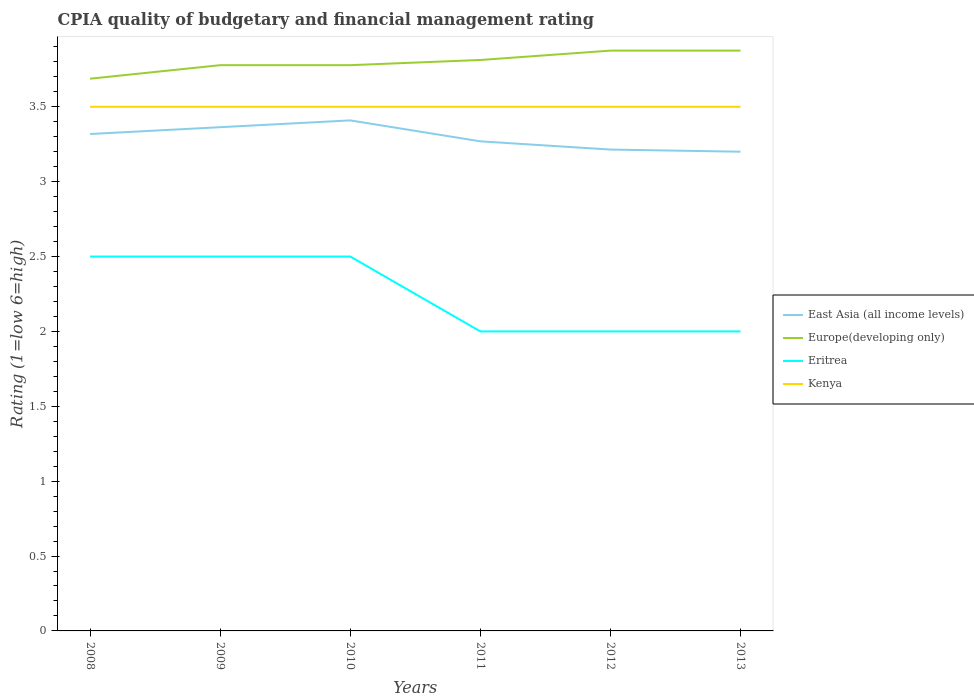How many different coloured lines are there?
Your answer should be compact. 4. Is the number of lines equal to the number of legend labels?
Offer a terse response. Yes. Across all years, what is the maximum CPIA rating in Europe(developing only)?
Make the answer very short. 3.69. What is the difference between the highest and the lowest CPIA rating in Europe(developing only)?
Ensure brevity in your answer.  3. Does the graph contain any zero values?
Give a very brief answer. No. Where does the legend appear in the graph?
Make the answer very short. Center right. How many legend labels are there?
Keep it short and to the point. 4. What is the title of the graph?
Your response must be concise. CPIA quality of budgetary and financial management rating. Does "Algeria" appear as one of the legend labels in the graph?
Your response must be concise. No. What is the label or title of the X-axis?
Keep it short and to the point. Years. What is the Rating (1=low 6=high) in East Asia (all income levels) in 2008?
Make the answer very short. 3.32. What is the Rating (1=low 6=high) in Europe(developing only) in 2008?
Keep it short and to the point. 3.69. What is the Rating (1=low 6=high) in Eritrea in 2008?
Make the answer very short. 2.5. What is the Rating (1=low 6=high) in East Asia (all income levels) in 2009?
Your answer should be very brief. 3.36. What is the Rating (1=low 6=high) of Europe(developing only) in 2009?
Your answer should be compact. 3.78. What is the Rating (1=low 6=high) in Eritrea in 2009?
Ensure brevity in your answer.  2.5. What is the Rating (1=low 6=high) of East Asia (all income levels) in 2010?
Make the answer very short. 3.41. What is the Rating (1=low 6=high) in Europe(developing only) in 2010?
Make the answer very short. 3.78. What is the Rating (1=low 6=high) in Eritrea in 2010?
Provide a short and direct response. 2.5. What is the Rating (1=low 6=high) in East Asia (all income levels) in 2011?
Ensure brevity in your answer.  3.27. What is the Rating (1=low 6=high) in Europe(developing only) in 2011?
Offer a very short reply. 3.81. What is the Rating (1=low 6=high) of Kenya in 2011?
Offer a terse response. 3.5. What is the Rating (1=low 6=high) of East Asia (all income levels) in 2012?
Provide a short and direct response. 3.21. What is the Rating (1=low 6=high) in Europe(developing only) in 2012?
Provide a short and direct response. 3.88. What is the Rating (1=low 6=high) in Kenya in 2012?
Your answer should be very brief. 3.5. What is the Rating (1=low 6=high) in East Asia (all income levels) in 2013?
Give a very brief answer. 3.2. What is the Rating (1=low 6=high) of Europe(developing only) in 2013?
Your response must be concise. 3.88. Across all years, what is the maximum Rating (1=low 6=high) in East Asia (all income levels)?
Your answer should be very brief. 3.41. Across all years, what is the maximum Rating (1=low 6=high) of Europe(developing only)?
Make the answer very short. 3.88. Across all years, what is the minimum Rating (1=low 6=high) of Europe(developing only)?
Make the answer very short. 3.69. What is the total Rating (1=low 6=high) in East Asia (all income levels) in the graph?
Provide a succinct answer. 19.77. What is the total Rating (1=low 6=high) of Europe(developing only) in the graph?
Provide a short and direct response. 22.81. What is the difference between the Rating (1=low 6=high) of East Asia (all income levels) in 2008 and that in 2009?
Provide a succinct answer. -0.05. What is the difference between the Rating (1=low 6=high) in Europe(developing only) in 2008 and that in 2009?
Your answer should be very brief. -0.09. What is the difference between the Rating (1=low 6=high) of East Asia (all income levels) in 2008 and that in 2010?
Keep it short and to the point. -0.09. What is the difference between the Rating (1=low 6=high) of Europe(developing only) in 2008 and that in 2010?
Your answer should be very brief. -0.09. What is the difference between the Rating (1=low 6=high) in Eritrea in 2008 and that in 2010?
Provide a succinct answer. 0. What is the difference between the Rating (1=low 6=high) in Kenya in 2008 and that in 2010?
Your answer should be very brief. 0. What is the difference between the Rating (1=low 6=high) of East Asia (all income levels) in 2008 and that in 2011?
Provide a short and direct response. 0.05. What is the difference between the Rating (1=low 6=high) of Europe(developing only) in 2008 and that in 2011?
Your answer should be very brief. -0.12. What is the difference between the Rating (1=low 6=high) of East Asia (all income levels) in 2008 and that in 2012?
Provide a succinct answer. 0.1. What is the difference between the Rating (1=low 6=high) of Europe(developing only) in 2008 and that in 2012?
Ensure brevity in your answer.  -0.19. What is the difference between the Rating (1=low 6=high) in Eritrea in 2008 and that in 2012?
Your answer should be compact. 0.5. What is the difference between the Rating (1=low 6=high) in East Asia (all income levels) in 2008 and that in 2013?
Keep it short and to the point. 0.12. What is the difference between the Rating (1=low 6=high) in Europe(developing only) in 2008 and that in 2013?
Offer a very short reply. -0.19. What is the difference between the Rating (1=low 6=high) in East Asia (all income levels) in 2009 and that in 2010?
Ensure brevity in your answer.  -0.05. What is the difference between the Rating (1=low 6=high) of Europe(developing only) in 2009 and that in 2010?
Give a very brief answer. 0. What is the difference between the Rating (1=low 6=high) of Kenya in 2009 and that in 2010?
Your answer should be very brief. 0. What is the difference between the Rating (1=low 6=high) in East Asia (all income levels) in 2009 and that in 2011?
Offer a very short reply. 0.09. What is the difference between the Rating (1=low 6=high) in Europe(developing only) in 2009 and that in 2011?
Provide a short and direct response. -0.03. What is the difference between the Rating (1=low 6=high) of Kenya in 2009 and that in 2011?
Give a very brief answer. 0. What is the difference between the Rating (1=low 6=high) in East Asia (all income levels) in 2009 and that in 2012?
Offer a terse response. 0.15. What is the difference between the Rating (1=low 6=high) in Europe(developing only) in 2009 and that in 2012?
Keep it short and to the point. -0.1. What is the difference between the Rating (1=low 6=high) in Eritrea in 2009 and that in 2012?
Your answer should be very brief. 0.5. What is the difference between the Rating (1=low 6=high) of East Asia (all income levels) in 2009 and that in 2013?
Your answer should be compact. 0.16. What is the difference between the Rating (1=low 6=high) in Europe(developing only) in 2009 and that in 2013?
Your answer should be compact. -0.1. What is the difference between the Rating (1=low 6=high) of Kenya in 2009 and that in 2013?
Your answer should be compact. 0. What is the difference between the Rating (1=low 6=high) in East Asia (all income levels) in 2010 and that in 2011?
Offer a terse response. 0.14. What is the difference between the Rating (1=low 6=high) in Europe(developing only) in 2010 and that in 2011?
Make the answer very short. -0.03. What is the difference between the Rating (1=low 6=high) in East Asia (all income levels) in 2010 and that in 2012?
Provide a succinct answer. 0.19. What is the difference between the Rating (1=low 6=high) of Europe(developing only) in 2010 and that in 2012?
Ensure brevity in your answer.  -0.1. What is the difference between the Rating (1=low 6=high) of Eritrea in 2010 and that in 2012?
Keep it short and to the point. 0.5. What is the difference between the Rating (1=low 6=high) in Kenya in 2010 and that in 2012?
Make the answer very short. 0. What is the difference between the Rating (1=low 6=high) in East Asia (all income levels) in 2010 and that in 2013?
Your answer should be compact. 0.21. What is the difference between the Rating (1=low 6=high) of Europe(developing only) in 2010 and that in 2013?
Your answer should be very brief. -0.1. What is the difference between the Rating (1=low 6=high) in East Asia (all income levels) in 2011 and that in 2012?
Your response must be concise. 0.05. What is the difference between the Rating (1=low 6=high) in Europe(developing only) in 2011 and that in 2012?
Your answer should be very brief. -0.06. What is the difference between the Rating (1=low 6=high) of Kenya in 2011 and that in 2012?
Keep it short and to the point. 0. What is the difference between the Rating (1=low 6=high) in East Asia (all income levels) in 2011 and that in 2013?
Give a very brief answer. 0.07. What is the difference between the Rating (1=low 6=high) of Europe(developing only) in 2011 and that in 2013?
Provide a short and direct response. -0.06. What is the difference between the Rating (1=low 6=high) of Eritrea in 2011 and that in 2013?
Make the answer very short. 0. What is the difference between the Rating (1=low 6=high) of East Asia (all income levels) in 2012 and that in 2013?
Keep it short and to the point. 0.01. What is the difference between the Rating (1=low 6=high) in Europe(developing only) in 2012 and that in 2013?
Offer a very short reply. 0. What is the difference between the Rating (1=low 6=high) of Eritrea in 2012 and that in 2013?
Ensure brevity in your answer.  0. What is the difference between the Rating (1=low 6=high) in Kenya in 2012 and that in 2013?
Provide a short and direct response. 0. What is the difference between the Rating (1=low 6=high) of East Asia (all income levels) in 2008 and the Rating (1=low 6=high) of Europe(developing only) in 2009?
Offer a terse response. -0.46. What is the difference between the Rating (1=low 6=high) of East Asia (all income levels) in 2008 and the Rating (1=low 6=high) of Eritrea in 2009?
Provide a succinct answer. 0.82. What is the difference between the Rating (1=low 6=high) of East Asia (all income levels) in 2008 and the Rating (1=low 6=high) of Kenya in 2009?
Provide a short and direct response. -0.18. What is the difference between the Rating (1=low 6=high) in Europe(developing only) in 2008 and the Rating (1=low 6=high) in Eritrea in 2009?
Your answer should be very brief. 1.19. What is the difference between the Rating (1=low 6=high) of Europe(developing only) in 2008 and the Rating (1=low 6=high) of Kenya in 2009?
Provide a short and direct response. 0.19. What is the difference between the Rating (1=low 6=high) of Eritrea in 2008 and the Rating (1=low 6=high) of Kenya in 2009?
Your response must be concise. -1. What is the difference between the Rating (1=low 6=high) of East Asia (all income levels) in 2008 and the Rating (1=low 6=high) of Europe(developing only) in 2010?
Make the answer very short. -0.46. What is the difference between the Rating (1=low 6=high) of East Asia (all income levels) in 2008 and the Rating (1=low 6=high) of Eritrea in 2010?
Your response must be concise. 0.82. What is the difference between the Rating (1=low 6=high) in East Asia (all income levels) in 2008 and the Rating (1=low 6=high) in Kenya in 2010?
Keep it short and to the point. -0.18. What is the difference between the Rating (1=low 6=high) in Europe(developing only) in 2008 and the Rating (1=low 6=high) in Eritrea in 2010?
Your answer should be very brief. 1.19. What is the difference between the Rating (1=low 6=high) of Europe(developing only) in 2008 and the Rating (1=low 6=high) of Kenya in 2010?
Your answer should be very brief. 0.19. What is the difference between the Rating (1=low 6=high) in East Asia (all income levels) in 2008 and the Rating (1=low 6=high) in Europe(developing only) in 2011?
Your response must be concise. -0.49. What is the difference between the Rating (1=low 6=high) in East Asia (all income levels) in 2008 and the Rating (1=low 6=high) in Eritrea in 2011?
Ensure brevity in your answer.  1.32. What is the difference between the Rating (1=low 6=high) of East Asia (all income levels) in 2008 and the Rating (1=low 6=high) of Kenya in 2011?
Ensure brevity in your answer.  -0.18. What is the difference between the Rating (1=low 6=high) of Europe(developing only) in 2008 and the Rating (1=low 6=high) of Eritrea in 2011?
Offer a terse response. 1.69. What is the difference between the Rating (1=low 6=high) of Europe(developing only) in 2008 and the Rating (1=low 6=high) of Kenya in 2011?
Your response must be concise. 0.19. What is the difference between the Rating (1=low 6=high) in East Asia (all income levels) in 2008 and the Rating (1=low 6=high) in Europe(developing only) in 2012?
Your response must be concise. -0.56. What is the difference between the Rating (1=low 6=high) in East Asia (all income levels) in 2008 and the Rating (1=low 6=high) in Eritrea in 2012?
Offer a very short reply. 1.32. What is the difference between the Rating (1=low 6=high) in East Asia (all income levels) in 2008 and the Rating (1=low 6=high) in Kenya in 2012?
Your response must be concise. -0.18. What is the difference between the Rating (1=low 6=high) of Europe(developing only) in 2008 and the Rating (1=low 6=high) of Eritrea in 2012?
Offer a terse response. 1.69. What is the difference between the Rating (1=low 6=high) in Europe(developing only) in 2008 and the Rating (1=low 6=high) in Kenya in 2012?
Your response must be concise. 0.19. What is the difference between the Rating (1=low 6=high) of East Asia (all income levels) in 2008 and the Rating (1=low 6=high) of Europe(developing only) in 2013?
Keep it short and to the point. -0.56. What is the difference between the Rating (1=low 6=high) in East Asia (all income levels) in 2008 and the Rating (1=low 6=high) in Eritrea in 2013?
Your answer should be very brief. 1.32. What is the difference between the Rating (1=low 6=high) of East Asia (all income levels) in 2008 and the Rating (1=low 6=high) of Kenya in 2013?
Offer a very short reply. -0.18. What is the difference between the Rating (1=low 6=high) of Europe(developing only) in 2008 and the Rating (1=low 6=high) of Eritrea in 2013?
Your answer should be compact. 1.69. What is the difference between the Rating (1=low 6=high) of Europe(developing only) in 2008 and the Rating (1=low 6=high) of Kenya in 2013?
Make the answer very short. 0.19. What is the difference between the Rating (1=low 6=high) in East Asia (all income levels) in 2009 and the Rating (1=low 6=high) in Europe(developing only) in 2010?
Keep it short and to the point. -0.41. What is the difference between the Rating (1=low 6=high) of East Asia (all income levels) in 2009 and the Rating (1=low 6=high) of Eritrea in 2010?
Provide a short and direct response. 0.86. What is the difference between the Rating (1=low 6=high) in East Asia (all income levels) in 2009 and the Rating (1=low 6=high) in Kenya in 2010?
Provide a short and direct response. -0.14. What is the difference between the Rating (1=low 6=high) in Europe(developing only) in 2009 and the Rating (1=low 6=high) in Eritrea in 2010?
Give a very brief answer. 1.28. What is the difference between the Rating (1=low 6=high) in Europe(developing only) in 2009 and the Rating (1=low 6=high) in Kenya in 2010?
Offer a terse response. 0.28. What is the difference between the Rating (1=low 6=high) in Eritrea in 2009 and the Rating (1=low 6=high) in Kenya in 2010?
Give a very brief answer. -1. What is the difference between the Rating (1=low 6=high) of East Asia (all income levels) in 2009 and the Rating (1=low 6=high) of Europe(developing only) in 2011?
Provide a succinct answer. -0.45. What is the difference between the Rating (1=low 6=high) of East Asia (all income levels) in 2009 and the Rating (1=low 6=high) of Eritrea in 2011?
Give a very brief answer. 1.36. What is the difference between the Rating (1=low 6=high) in East Asia (all income levels) in 2009 and the Rating (1=low 6=high) in Kenya in 2011?
Your answer should be compact. -0.14. What is the difference between the Rating (1=low 6=high) of Europe(developing only) in 2009 and the Rating (1=low 6=high) of Eritrea in 2011?
Your answer should be compact. 1.78. What is the difference between the Rating (1=low 6=high) of Europe(developing only) in 2009 and the Rating (1=low 6=high) of Kenya in 2011?
Your answer should be compact. 0.28. What is the difference between the Rating (1=low 6=high) in East Asia (all income levels) in 2009 and the Rating (1=low 6=high) in Europe(developing only) in 2012?
Your answer should be very brief. -0.51. What is the difference between the Rating (1=low 6=high) in East Asia (all income levels) in 2009 and the Rating (1=low 6=high) in Eritrea in 2012?
Provide a succinct answer. 1.36. What is the difference between the Rating (1=low 6=high) of East Asia (all income levels) in 2009 and the Rating (1=low 6=high) of Kenya in 2012?
Provide a succinct answer. -0.14. What is the difference between the Rating (1=low 6=high) of Europe(developing only) in 2009 and the Rating (1=low 6=high) of Eritrea in 2012?
Keep it short and to the point. 1.78. What is the difference between the Rating (1=low 6=high) of Europe(developing only) in 2009 and the Rating (1=low 6=high) of Kenya in 2012?
Keep it short and to the point. 0.28. What is the difference between the Rating (1=low 6=high) in East Asia (all income levels) in 2009 and the Rating (1=low 6=high) in Europe(developing only) in 2013?
Offer a terse response. -0.51. What is the difference between the Rating (1=low 6=high) of East Asia (all income levels) in 2009 and the Rating (1=low 6=high) of Eritrea in 2013?
Your response must be concise. 1.36. What is the difference between the Rating (1=low 6=high) in East Asia (all income levels) in 2009 and the Rating (1=low 6=high) in Kenya in 2013?
Provide a short and direct response. -0.14. What is the difference between the Rating (1=low 6=high) in Europe(developing only) in 2009 and the Rating (1=low 6=high) in Eritrea in 2013?
Offer a terse response. 1.78. What is the difference between the Rating (1=low 6=high) of Europe(developing only) in 2009 and the Rating (1=low 6=high) of Kenya in 2013?
Make the answer very short. 0.28. What is the difference between the Rating (1=low 6=high) in East Asia (all income levels) in 2010 and the Rating (1=low 6=high) in Europe(developing only) in 2011?
Offer a terse response. -0.4. What is the difference between the Rating (1=low 6=high) of East Asia (all income levels) in 2010 and the Rating (1=low 6=high) of Eritrea in 2011?
Your response must be concise. 1.41. What is the difference between the Rating (1=low 6=high) of East Asia (all income levels) in 2010 and the Rating (1=low 6=high) of Kenya in 2011?
Provide a short and direct response. -0.09. What is the difference between the Rating (1=low 6=high) of Europe(developing only) in 2010 and the Rating (1=low 6=high) of Eritrea in 2011?
Offer a terse response. 1.78. What is the difference between the Rating (1=low 6=high) in Europe(developing only) in 2010 and the Rating (1=low 6=high) in Kenya in 2011?
Make the answer very short. 0.28. What is the difference between the Rating (1=low 6=high) in Eritrea in 2010 and the Rating (1=low 6=high) in Kenya in 2011?
Provide a short and direct response. -1. What is the difference between the Rating (1=low 6=high) in East Asia (all income levels) in 2010 and the Rating (1=low 6=high) in Europe(developing only) in 2012?
Your answer should be compact. -0.47. What is the difference between the Rating (1=low 6=high) in East Asia (all income levels) in 2010 and the Rating (1=low 6=high) in Eritrea in 2012?
Your answer should be compact. 1.41. What is the difference between the Rating (1=low 6=high) of East Asia (all income levels) in 2010 and the Rating (1=low 6=high) of Kenya in 2012?
Make the answer very short. -0.09. What is the difference between the Rating (1=low 6=high) of Europe(developing only) in 2010 and the Rating (1=low 6=high) of Eritrea in 2012?
Your answer should be compact. 1.78. What is the difference between the Rating (1=low 6=high) of Europe(developing only) in 2010 and the Rating (1=low 6=high) of Kenya in 2012?
Your answer should be very brief. 0.28. What is the difference between the Rating (1=low 6=high) of Eritrea in 2010 and the Rating (1=low 6=high) of Kenya in 2012?
Keep it short and to the point. -1. What is the difference between the Rating (1=low 6=high) of East Asia (all income levels) in 2010 and the Rating (1=low 6=high) of Europe(developing only) in 2013?
Your response must be concise. -0.47. What is the difference between the Rating (1=low 6=high) in East Asia (all income levels) in 2010 and the Rating (1=low 6=high) in Eritrea in 2013?
Offer a terse response. 1.41. What is the difference between the Rating (1=low 6=high) of East Asia (all income levels) in 2010 and the Rating (1=low 6=high) of Kenya in 2013?
Your response must be concise. -0.09. What is the difference between the Rating (1=low 6=high) in Europe(developing only) in 2010 and the Rating (1=low 6=high) in Eritrea in 2013?
Give a very brief answer. 1.78. What is the difference between the Rating (1=low 6=high) of Europe(developing only) in 2010 and the Rating (1=low 6=high) of Kenya in 2013?
Offer a terse response. 0.28. What is the difference between the Rating (1=low 6=high) of East Asia (all income levels) in 2011 and the Rating (1=low 6=high) of Europe(developing only) in 2012?
Provide a succinct answer. -0.61. What is the difference between the Rating (1=low 6=high) of East Asia (all income levels) in 2011 and the Rating (1=low 6=high) of Eritrea in 2012?
Keep it short and to the point. 1.27. What is the difference between the Rating (1=low 6=high) of East Asia (all income levels) in 2011 and the Rating (1=low 6=high) of Kenya in 2012?
Your answer should be very brief. -0.23. What is the difference between the Rating (1=low 6=high) in Europe(developing only) in 2011 and the Rating (1=low 6=high) in Eritrea in 2012?
Provide a short and direct response. 1.81. What is the difference between the Rating (1=low 6=high) of Europe(developing only) in 2011 and the Rating (1=low 6=high) of Kenya in 2012?
Give a very brief answer. 0.31. What is the difference between the Rating (1=low 6=high) of East Asia (all income levels) in 2011 and the Rating (1=low 6=high) of Europe(developing only) in 2013?
Offer a terse response. -0.61. What is the difference between the Rating (1=low 6=high) in East Asia (all income levels) in 2011 and the Rating (1=low 6=high) in Eritrea in 2013?
Your answer should be compact. 1.27. What is the difference between the Rating (1=low 6=high) in East Asia (all income levels) in 2011 and the Rating (1=low 6=high) in Kenya in 2013?
Offer a very short reply. -0.23. What is the difference between the Rating (1=low 6=high) in Europe(developing only) in 2011 and the Rating (1=low 6=high) in Eritrea in 2013?
Keep it short and to the point. 1.81. What is the difference between the Rating (1=low 6=high) of Europe(developing only) in 2011 and the Rating (1=low 6=high) of Kenya in 2013?
Your response must be concise. 0.31. What is the difference between the Rating (1=low 6=high) in East Asia (all income levels) in 2012 and the Rating (1=low 6=high) in Europe(developing only) in 2013?
Ensure brevity in your answer.  -0.66. What is the difference between the Rating (1=low 6=high) of East Asia (all income levels) in 2012 and the Rating (1=low 6=high) of Eritrea in 2013?
Provide a succinct answer. 1.21. What is the difference between the Rating (1=low 6=high) in East Asia (all income levels) in 2012 and the Rating (1=low 6=high) in Kenya in 2013?
Provide a short and direct response. -0.29. What is the difference between the Rating (1=low 6=high) of Europe(developing only) in 2012 and the Rating (1=low 6=high) of Eritrea in 2013?
Keep it short and to the point. 1.88. What is the difference between the Rating (1=low 6=high) in Eritrea in 2012 and the Rating (1=low 6=high) in Kenya in 2013?
Keep it short and to the point. -1.5. What is the average Rating (1=low 6=high) in East Asia (all income levels) per year?
Offer a terse response. 3.3. What is the average Rating (1=low 6=high) in Europe(developing only) per year?
Your answer should be very brief. 3.8. What is the average Rating (1=low 6=high) of Eritrea per year?
Offer a very short reply. 2.25. In the year 2008, what is the difference between the Rating (1=low 6=high) in East Asia (all income levels) and Rating (1=low 6=high) in Europe(developing only)?
Offer a very short reply. -0.37. In the year 2008, what is the difference between the Rating (1=low 6=high) of East Asia (all income levels) and Rating (1=low 6=high) of Eritrea?
Provide a succinct answer. 0.82. In the year 2008, what is the difference between the Rating (1=low 6=high) of East Asia (all income levels) and Rating (1=low 6=high) of Kenya?
Ensure brevity in your answer.  -0.18. In the year 2008, what is the difference between the Rating (1=low 6=high) of Europe(developing only) and Rating (1=low 6=high) of Eritrea?
Keep it short and to the point. 1.19. In the year 2008, what is the difference between the Rating (1=low 6=high) of Europe(developing only) and Rating (1=low 6=high) of Kenya?
Your response must be concise. 0.19. In the year 2008, what is the difference between the Rating (1=low 6=high) of Eritrea and Rating (1=low 6=high) of Kenya?
Ensure brevity in your answer.  -1. In the year 2009, what is the difference between the Rating (1=low 6=high) of East Asia (all income levels) and Rating (1=low 6=high) of Europe(developing only)?
Offer a very short reply. -0.41. In the year 2009, what is the difference between the Rating (1=low 6=high) in East Asia (all income levels) and Rating (1=low 6=high) in Eritrea?
Give a very brief answer. 0.86. In the year 2009, what is the difference between the Rating (1=low 6=high) of East Asia (all income levels) and Rating (1=low 6=high) of Kenya?
Your response must be concise. -0.14. In the year 2009, what is the difference between the Rating (1=low 6=high) in Europe(developing only) and Rating (1=low 6=high) in Eritrea?
Your answer should be very brief. 1.28. In the year 2009, what is the difference between the Rating (1=low 6=high) in Europe(developing only) and Rating (1=low 6=high) in Kenya?
Give a very brief answer. 0.28. In the year 2010, what is the difference between the Rating (1=low 6=high) of East Asia (all income levels) and Rating (1=low 6=high) of Europe(developing only)?
Provide a short and direct response. -0.37. In the year 2010, what is the difference between the Rating (1=low 6=high) of East Asia (all income levels) and Rating (1=low 6=high) of Eritrea?
Your answer should be very brief. 0.91. In the year 2010, what is the difference between the Rating (1=low 6=high) of East Asia (all income levels) and Rating (1=low 6=high) of Kenya?
Offer a terse response. -0.09. In the year 2010, what is the difference between the Rating (1=low 6=high) of Europe(developing only) and Rating (1=low 6=high) of Eritrea?
Keep it short and to the point. 1.28. In the year 2010, what is the difference between the Rating (1=low 6=high) of Europe(developing only) and Rating (1=low 6=high) of Kenya?
Offer a terse response. 0.28. In the year 2010, what is the difference between the Rating (1=low 6=high) in Eritrea and Rating (1=low 6=high) in Kenya?
Your response must be concise. -1. In the year 2011, what is the difference between the Rating (1=low 6=high) of East Asia (all income levels) and Rating (1=low 6=high) of Europe(developing only)?
Provide a succinct answer. -0.54. In the year 2011, what is the difference between the Rating (1=low 6=high) in East Asia (all income levels) and Rating (1=low 6=high) in Eritrea?
Your answer should be very brief. 1.27. In the year 2011, what is the difference between the Rating (1=low 6=high) of East Asia (all income levels) and Rating (1=low 6=high) of Kenya?
Offer a very short reply. -0.23. In the year 2011, what is the difference between the Rating (1=low 6=high) of Europe(developing only) and Rating (1=low 6=high) of Eritrea?
Your answer should be very brief. 1.81. In the year 2011, what is the difference between the Rating (1=low 6=high) of Europe(developing only) and Rating (1=low 6=high) of Kenya?
Your response must be concise. 0.31. In the year 2011, what is the difference between the Rating (1=low 6=high) in Eritrea and Rating (1=low 6=high) in Kenya?
Give a very brief answer. -1.5. In the year 2012, what is the difference between the Rating (1=low 6=high) in East Asia (all income levels) and Rating (1=low 6=high) in Europe(developing only)?
Ensure brevity in your answer.  -0.66. In the year 2012, what is the difference between the Rating (1=low 6=high) of East Asia (all income levels) and Rating (1=low 6=high) of Eritrea?
Offer a very short reply. 1.21. In the year 2012, what is the difference between the Rating (1=low 6=high) of East Asia (all income levels) and Rating (1=low 6=high) of Kenya?
Your response must be concise. -0.29. In the year 2012, what is the difference between the Rating (1=low 6=high) of Europe(developing only) and Rating (1=low 6=high) of Eritrea?
Ensure brevity in your answer.  1.88. In the year 2013, what is the difference between the Rating (1=low 6=high) in East Asia (all income levels) and Rating (1=low 6=high) in Europe(developing only)?
Your answer should be compact. -0.68. In the year 2013, what is the difference between the Rating (1=low 6=high) in East Asia (all income levels) and Rating (1=low 6=high) in Eritrea?
Your response must be concise. 1.2. In the year 2013, what is the difference between the Rating (1=low 6=high) of East Asia (all income levels) and Rating (1=low 6=high) of Kenya?
Your answer should be compact. -0.3. In the year 2013, what is the difference between the Rating (1=low 6=high) in Europe(developing only) and Rating (1=low 6=high) in Eritrea?
Make the answer very short. 1.88. In the year 2013, what is the difference between the Rating (1=low 6=high) in Eritrea and Rating (1=low 6=high) in Kenya?
Offer a terse response. -1.5. What is the ratio of the Rating (1=low 6=high) of East Asia (all income levels) in 2008 to that in 2009?
Offer a very short reply. 0.99. What is the ratio of the Rating (1=low 6=high) of Europe(developing only) in 2008 to that in 2009?
Your answer should be very brief. 0.98. What is the ratio of the Rating (1=low 6=high) of East Asia (all income levels) in 2008 to that in 2010?
Offer a very short reply. 0.97. What is the ratio of the Rating (1=low 6=high) of Europe(developing only) in 2008 to that in 2010?
Your answer should be very brief. 0.98. What is the ratio of the Rating (1=low 6=high) of East Asia (all income levels) in 2008 to that in 2011?
Your answer should be very brief. 1.01. What is the ratio of the Rating (1=low 6=high) in Europe(developing only) in 2008 to that in 2011?
Give a very brief answer. 0.97. What is the ratio of the Rating (1=low 6=high) of Eritrea in 2008 to that in 2011?
Make the answer very short. 1.25. What is the ratio of the Rating (1=low 6=high) in Kenya in 2008 to that in 2011?
Your answer should be compact. 1. What is the ratio of the Rating (1=low 6=high) of East Asia (all income levels) in 2008 to that in 2012?
Provide a short and direct response. 1.03. What is the ratio of the Rating (1=low 6=high) in Europe(developing only) in 2008 to that in 2012?
Your answer should be very brief. 0.95. What is the ratio of the Rating (1=low 6=high) of Eritrea in 2008 to that in 2012?
Provide a succinct answer. 1.25. What is the ratio of the Rating (1=low 6=high) in Kenya in 2008 to that in 2012?
Ensure brevity in your answer.  1. What is the ratio of the Rating (1=low 6=high) of East Asia (all income levels) in 2008 to that in 2013?
Keep it short and to the point. 1.04. What is the ratio of the Rating (1=low 6=high) in Europe(developing only) in 2008 to that in 2013?
Make the answer very short. 0.95. What is the ratio of the Rating (1=low 6=high) of Eritrea in 2008 to that in 2013?
Keep it short and to the point. 1.25. What is the ratio of the Rating (1=low 6=high) in Kenya in 2008 to that in 2013?
Make the answer very short. 1. What is the ratio of the Rating (1=low 6=high) in East Asia (all income levels) in 2009 to that in 2010?
Provide a short and direct response. 0.99. What is the ratio of the Rating (1=low 6=high) of Eritrea in 2009 to that in 2010?
Your answer should be very brief. 1. What is the ratio of the Rating (1=low 6=high) in Kenya in 2009 to that in 2010?
Your answer should be compact. 1. What is the ratio of the Rating (1=low 6=high) in East Asia (all income levels) in 2009 to that in 2011?
Make the answer very short. 1.03. What is the ratio of the Rating (1=low 6=high) in Europe(developing only) in 2009 to that in 2011?
Offer a terse response. 0.99. What is the ratio of the Rating (1=low 6=high) of Kenya in 2009 to that in 2011?
Your response must be concise. 1. What is the ratio of the Rating (1=low 6=high) in East Asia (all income levels) in 2009 to that in 2012?
Your answer should be very brief. 1.05. What is the ratio of the Rating (1=low 6=high) of Europe(developing only) in 2009 to that in 2012?
Offer a terse response. 0.97. What is the ratio of the Rating (1=low 6=high) in Kenya in 2009 to that in 2012?
Your answer should be very brief. 1. What is the ratio of the Rating (1=low 6=high) of East Asia (all income levels) in 2009 to that in 2013?
Ensure brevity in your answer.  1.05. What is the ratio of the Rating (1=low 6=high) of Europe(developing only) in 2009 to that in 2013?
Offer a terse response. 0.97. What is the ratio of the Rating (1=low 6=high) in Eritrea in 2009 to that in 2013?
Your response must be concise. 1.25. What is the ratio of the Rating (1=low 6=high) of Kenya in 2009 to that in 2013?
Make the answer very short. 1. What is the ratio of the Rating (1=low 6=high) in East Asia (all income levels) in 2010 to that in 2011?
Provide a succinct answer. 1.04. What is the ratio of the Rating (1=low 6=high) of Europe(developing only) in 2010 to that in 2011?
Your response must be concise. 0.99. What is the ratio of the Rating (1=low 6=high) of Kenya in 2010 to that in 2011?
Give a very brief answer. 1. What is the ratio of the Rating (1=low 6=high) in East Asia (all income levels) in 2010 to that in 2012?
Your answer should be compact. 1.06. What is the ratio of the Rating (1=low 6=high) in Europe(developing only) in 2010 to that in 2012?
Your response must be concise. 0.97. What is the ratio of the Rating (1=low 6=high) in Eritrea in 2010 to that in 2012?
Offer a very short reply. 1.25. What is the ratio of the Rating (1=low 6=high) of East Asia (all income levels) in 2010 to that in 2013?
Make the answer very short. 1.07. What is the ratio of the Rating (1=low 6=high) in Europe(developing only) in 2010 to that in 2013?
Offer a very short reply. 0.97. What is the ratio of the Rating (1=low 6=high) in Kenya in 2010 to that in 2013?
Your answer should be very brief. 1. What is the ratio of the Rating (1=low 6=high) of East Asia (all income levels) in 2011 to that in 2012?
Provide a short and direct response. 1.02. What is the ratio of the Rating (1=low 6=high) of Europe(developing only) in 2011 to that in 2012?
Make the answer very short. 0.98. What is the ratio of the Rating (1=low 6=high) of East Asia (all income levels) in 2011 to that in 2013?
Your response must be concise. 1.02. What is the ratio of the Rating (1=low 6=high) in Europe(developing only) in 2011 to that in 2013?
Your answer should be compact. 0.98. What is the ratio of the Rating (1=low 6=high) in Kenya in 2011 to that in 2013?
Provide a short and direct response. 1. What is the ratio of the Rating (1=low 6=high) in East Asia (all income levels) in 2012 to that in 2013?
Provide a succinct answer. 1. What is the ratio of the Rating (1=low 6=high) in Europe(developing only) in 2012 to that in 2013?
Offer a very short reply. 1. What is the difference between the highest and the second highest Rating (1=low 6=high) of East Asia (all income levels)?
Your answer should be very brief. 0.05. What is the difference between the highest and the second highest Rating (1=low 6=high) in Kenya?
Keep it short and to the point. 0. What is the difference between the highest and the lowest Rating (1=low 6=high) of East Asia (all income levels)?
Your response must be concise. 0.21. What is the difference between the highest and the lowest Rating (1=low 6=high) of Europe(developing only)?
Provide a succinct answer. 0.19. What is the difference between the highest and the lowest Rating (1=low 6=high) in Kenya?
Ensure brevity in your answer.  0. 